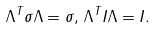Convert formula to latex. <formula><loc_0><loc_0><loc_500><loc_500>\Lambda ^ { T } \sigma \Lambda = \sigma , \, \Lambda ^ { T } I \Lambda = I .</formula> 